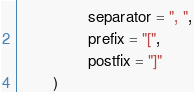<code> <loc_0><loc_0><loc_500><loc_500><_Kotlin_>                separator = ", ",
                prefix = "[",
                postfix = "]"
        )
</code> 